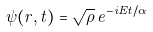Convert formula to latex. <formula><loc_0><loc_0><loc_500><loc_500>\psi ( r , t ) = \sqrt { \rho } \, e ^ { - i E t / \alpha }</formula> 